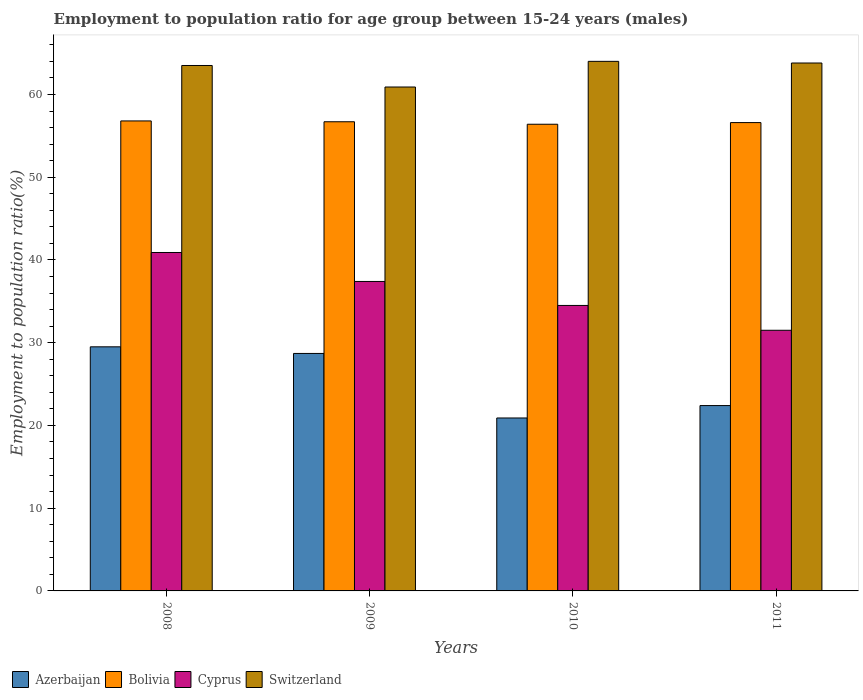How many different coloured bars are there?
Provide a short and direct response. 4. How many groups of bars are there?
Keep it short and to the point. 4. Are the number of bars on each tick of the X-axis equal?
Keep it short and to the point. Yes. In how many cases, is the number of bars for a given year not equal to the number of legend labels?
Your response must be concise. 0. What is the employment to population ratio in Cyprus in 2010?
Offer a very short reply. 34.5. Across all years, what is the minimum employment to population ratio in Bolivia?
Provide a succinct answer. 56.4. What is the total employment to population ratio in Switzerland in the graph?
Your answer should be very brief. 252.2. What is the difference between the employment to population ratio in Bolivia in 2008 and the employment to population ratio in Cyprus in 2010?
Your answer should be compact. 22.3. What is the average employment to population ratio in Cyprus per year?
Keep it short and to the point. 36.08. In the year 2010, what is the difference between the employment to population ratio in Bolivia and employment to population ratio in Azerbaijan?
Provide a succinct answer. 35.5. What is the ratio of the employment to population ratio in Cyprus in 2008 to that in 2009?
Offer a terse response. 1.09. What is the difference between the highest and the second highest employment to population ratio in Cyprus?
Provide a succinct answer. 3.5. What is the difference between the highest and the lowest employment to population ratio in Bolivia?
Provide a short and direct response. 0.4. In how many years, is the employment to population ratio in Cyprus greater than the average employment to population ratio in Cyprus taken over all years?
Offer a terse response. 2. Is the sum of the employment to population ratio in Azerbaijan in 2009 and 2010 greater than the maximum employment to population ratio in Cyprus across all years?
Your answer should be compact. Yes. Is it the case that in every year, the sum of the employment to population ratio in Switzerland and employment to population ratio in Cyprus is greater than the sum of employment to population ratio in Bolivia and employment to population ratio in Azerbaijan?
Ensure brevity in your answer.  Yes. What does the 3rd bar from the left in 2008 represents?
Provide a short and direct response. Cyprus. Is it the case that in every year, the sum of the employment to population ratio in Azerbaijan and employment to population ratio in Switzerland is greater than the employment to population ratio in Bolivia?
Provide a short and direct response. Yes. How many bars are there?
Provide a short and direct response. 16. How many years are there in the graph?
Your response must be concise. 4. Are the values on the major ticks of Y-axis written in scientific E-notation?
Offer a terse response. No. Does the graph contain any zero values?
Offer a very short reply. No. Does the graph contain grids?
Your answer should be very brief. No. How many legend labels are there?
Keep it short and to the point. 4. What is the title of the graph?
Give a very brief answer. Employment to population ratio for age group between 15-24 years (males). Does "Mexico" appear as one of the legend labels in the graph?
Provide a short and direct response. No. What is the label or title of the X-axis?
Give a very brief answer. Years. What is the Employment to population ratio(%) of Azerbaijan in 2008?
Provide a short and direct response. 29.5. What is the Employment to population ratio(%) in Bolivia in 2008?
Offer a very short reply. 56.8. What is the Employment to population ratio(%) in Cyprus in 2008?
Provide a succinct answer. 40.9. What is the Employment to population ratio(%) in Switzerland in 2008?
Provide a short and direct response. 63.5. What is the Employment to population ratio(%) of Azerbaijan in 2009?
Make the answer very short. 28.7. What is the Employment to population ratio(%) of Bolivia in 2009?
Keep it short and to the point. 56.7. What is the Employment to population ratio(%) of Cyprus in 2009?
Provide a succinct answer. 37.4. What is the Employment to population ratio(%) of Switzerland in 2009?
Provide a short and direct response. 60.9. What is the Employment to population ratio(%) in Azerbaijan in 2010?
Your response must be concise. 20.9. What is the Employment to population ratio(%) in Bolivia in 2010?
Make the answer very short. 56.4. What is the Employment to population ratio(%) of Cyprus in 2010?
Ensure brevity in your answer.  34.5. What is the Employment to population ratio(%) of Azerbaijan in 2011?
Offer a terse response. 22.4. What is the Employment to population ratio(%) in Bolivia in 2011?
Ensure brevity in your answer.  56.6. What is the Employment to population ratio(%) in Cyprus in 2011?
Your answer should be compact. 31.5. What is the Employment to population ratio(%) in Switzerland in 2011?
Your answer should be compact. 63.8. Across all years, what is the maximum Employment to population ratio(%) of Azerbaijan?
Your response must be concise. 29.5. Across all years, what is the maximum Employment to population ratio(%) in Bolivia?
Provide a succinct answer. 56.8. Across all years, what is the maximum Employment to population ratio(%) in Cyprus?
Your response must be concise. 40.9. Across all years, what is the maximum Employment to population ratio(%) of Switzerland?
Provide a short and direct response. 64. Across all years, what is the minimum Employment to population ratio(%) of Azerbaijan?
Your response must be concise. 20.9. Across all years, what is the minimum Employment to population ratio(%) of Bolivia?
Ensure brevity in your answer.  56.4. Across all years, what is the minimum Employment to population ratio(%) of Cyprus?
Make the answer very short. 31.5. Across all years, what is the minimum Employment to population ratio(%) in Switzerland?
Ensure brevity in your answer.  60.9. What is the total Employment to population ratio(%) in Azerbaijan in the graph?
Your answer should be very brief. 101.5. What is the total Employment to population ratio(%) in Bolivia in the graph?
Offer a terse response. 226.5. What is the total Employment to population ratio(%) in Cyprus in the graph?
Keep it short and to the point. 144.3. What is the total Employment to population ratio(%) of Switzerland in the graph?
Your response must be concise. 252.2. What is the difference between the Employment to population ratio(%) of Bolivia in 2008 and that in 2009?
Give a very brief answer. 0.1. What is the difference between the Employment to population ratio(%) in Cyprus in 2008 and that in 2009?
Give a very brief answer. 3.5. What is the difference between the Employment to population ratio(%) of Switzerland in 2008 and that in 2009?
Your answer should be very brief. 2.6. What is the difference between the Employment to population ratio(%) in Bolivia in 2008 and that in 2010?
Offer a very short reply. 0.4. What is the difference between the Employment to population ratio(%) in Azerbaijan in 2008 and that in 2011?
Give a very brief answer. 7.1. What is the difference between the Employment to population ratio(%) in Bolivia in 2008 and that in 2011?
Make the answer very short. 0.2. What is the difference between the Employment to population ratio(%) of Cyprus in 2008 and that in 2011?
Give a very brief answer. 9.4. What is the difference between the Employment to population ratio(%) of Switzerland in 2008 and that in 2011?
Ensure brevity in your answer.  -0.3. What is the difference between the Employment to population ratio(%) in Azerbaijan in 2009 and that in 2010?
Offer a very short reply. 7.8. What is the difference between the Employment to population ratio(%) of Bolivia in 2009 and that in 2010?
Give a very brief answer. 0.3. What is the difference between the Employment to population ratio(%) in Cyprus in 2009 and that in 2010?
Your answer should be very brief. 2.9. What is the difference between the Employment to population ratio(%) of Switzerland in 2009 and that in 2010?
Your answer should be very brief. -3.1. What is the difference between the Employment to population ratio(%) of Azerbaijan in 2009 and that in 2011?
Ensure brevity in your answer.  6.3. What is the difference between the Employment to population ratio(%) of Cyprus in 2009 and that in 2011?
Give a very brief answer. 5.9. What is the difference between the Employment to population ratio(%) in Switzerland in 2009 and that in 2011?
Provide a succinct answer. -2.9. What is the difference between the Employment to population ratio(%) in Cyprus in 2010 and that in 2011?
Ensure brevity in your answer.  3. What is the difference between the Employment to population ratio(%) of Azerbaijan in 2008 and the Employment to population ratio(%) of Bolivia in 2009?
Offer a terse response. -27.2. What is the difference between the Employment to population ratio(%) of Azerbaijan in 2008 and the Employment to population ratio(%) of Switzerland in 2009?
Your answer should be compact. -31.4. What is the difference between the Employment to population ratio(%) of Bolivia in 2008 and the Employment to population ratio(%) of Switzerland in 2009?
Your response must be concise. -4.1. What is the difference between the Employment to population ratio(%) in Azerbaijan in 2008 and the Employment to population ratio(%) in Bolivia in 2010?
Keep it short and to the point. -26.9. What is the difference between the Employment to population ratio(%) in Azerbaijan in 2008 and the Employment to population ratio(%) in Cyprus in 2010?
Offer a very short reply. -5. What is the difference between the Employment to population ratio(%) of Azerbaijan in 2008 and the Employment to population ratio(%) of Switzerland in 2010?
Make the answer very short. -34.5. What is the difference between the Employment to population ratio(%) of Bolivia in 2008 and the Employment to population ratio(%) of Cyprus in 2010?
Your answer should be very brief. 22.3. What is the difference between the Employment to population ratio(%) in Cyprus in 2008 and the Employment to population ratio(%) in Switzerland in 2010?
Your answer should be compact. -23.1. What is the difference between the Employment to population ratio(%) of Azerbaijan in 2008 and the Employment to population ratio(%) of Bolivia in 2011?
Give a very brief answer. -27.1. What is the difference between the Employment to population ratio(%) in Azerbaijan in 2008 and the Employment to population ratio(%) in Switzerland in 2011?
Make the answer very short. -34.3. What is the difference between the Employment to population ratio(%) in Bolivia in 2008 and the Employment to population ratio(%) in Cyprus in 2011?
Your answer should be very brief. 25.3. What is the difference between the Employment to population ratio(%) in Cyprus in 2008 and the Employment to population ratio(%) in Switzerland in 2011?
Ensure brevity in your answer.  -22.9. What is the difference between the Employment to population ratio(%) in Azerbaijan in 2009 and the Employment to population ratio(%) in Bolivia in 2010?
Provide a short and direct response. -27.7. What is the difference between the Employment to population ratio(%) in Azerbaijan in 2009 and the Employment to population ratio(%) in Cyprus in 2010?
Keep it short and to the point. -5.8. What is the difference between the Employment to population ratio(%) in Azerbaijan in 2009 and the Employment to population ratio(%) in Switzerland in 2010?
Offer a terse response. -35.3. What is the difference between the Employment to population ratio(%) in Bolivia in 2009 and the Employment to population ratio(%) in Switzerland in 2010?
Your answer should be very brief. -7.3. What is the difference between the Employment to population ratio(%) of Cyprus in 2009 and the Employment to population ratio(%) of Switzerland in 2010?
Provide a short and direct response. -26.6. What is the difference between the Employment to population ratio(%) of Azerbaijan in 2009 and the Employment to population ratio(%) of Bolivia in 2011?
Your response must be concise. -27.9. What is the difference between the Employment to population ratio(%) in Azerbaijan in 2009 and the Employment to population ratio(%) in Cyprus in 2011?
Your response must be concise. -2.8. What is the difference between the Employment to population ratio(%) in Azerbaijan in 2009 and the Employment to population ratio(%) in Switzerland in 2011?
Your answer should be very brief. -35.1. What is the difference between the Employment to population ratio(%) of Bolivia in 2009 and the Employment to population ratio(%) of Cyprus in 2011?
Ensure brevity in your answer.  25.2. What is the difference between the Employment to population ratio(%) of Bolivia in 2009 and the Employment to population ratio(%) of Switzerland in 2011?
Provide a succinct answer. -7.1. What is the difference between the Employment to population ratio(%) in Cyprus in 2009 and the Employment to population ratio(%) in Switzerland in 2011?
Your answer should be very brief. -26.4. What is the difference between the Employment to population ratio(%) of Azerbaijan in 2010 and the Employment to population ratio(%) of Bolivia in 2011?
Ensure brevity in your answer.  -35.7. What is the difference between the Employment to population ratio(%) in Azerbaijan in 2010 and the Employment to population ratio(%) in Switzerland in 2011?
Ensure brevity in your answer.  -42.9. What is the difference between the Employment to population ratio(%) of Bolivia in 2010 and the Employment to population ratio(%) of Cyprus in 2011?
Your response must be concise. 24.9. What is the difference between the Employment to population ratio(%) in Bolivia in 2010 and the Employment to population ratio(%) in Switzerland in 2011?
Make the answer very short. -7.4. What is the difference between the Employment to population ratio(%) in Cyprus in 2010 and the Employment to population ratio(%) in Switzerland in 2011?
Provide a short and direct response. -29.3. What is the average Employment to population ratio(%) in Azerbaijan per year?
Your answer should be compact. 25.38. What is the average Employment to population ratio(%) in Bolivia per year?
Provide a short and direct response. 56.62. What is the average Employment to population ratio(%) of Cyprus per year?
Your answer should be compact. 36.08. What is the average Employment to population ratio(%) in Switzerland per year?
Your answer should be compact. 63.05. In the year 2008, what is the difference between the Employment to population ratio(%) of Azerbaijan and Employment to population ratio(%) of Bolivia?
Give a very brief answer. -27.3. In the year 2008, what is the difference between the Employment to population ratio(%) in Azerbaijan and Employment to population ratio(%) in Cyprus?
Give a very brief answer. -11.4. In the year 2008, what is the difference between the Employment to population ratio(%) of Azerbaijan and Employment to population ratio(%) of Switzerland?
Your response must be concise. -34. In the year 2008, what is the difference between the Employment to population ratio(%) in Bolivia and Employment to population ratio(%) in Switzerland?
Ensure brevity in your answer.  -6.7. In the year 2008, what is the difference between the Employment to population ratio(%) in Cyprus and Employment to population ratio(%) in Switzerland?
Keep it short and to the point. -22.6. In the year 2009, what is the difference between the Employment to population ratio(%) in Azerbaijan and Employment to population ratio(%) in Bolivia?
Offer a terse response. -28. In the year 2009, what is the difference between the Employment to population ratio(%) in Azerbaijan and Employment to population ratio(%) in Switzerland?
Offer a terse response. -32.2. In the year 2009, what is the difference between the Employment to population ratio(%) of Bolivia and Employment to population ratio(%) of Cyprus?
Give a very brief answer. 19.3. In the year 2009, what is the difference between the Employment to population ratio(%) in Bolivia and Employment to population ratio(%) in Switzerland?
Offer a very short reply. -4.2. In the year 2009, what is the difference between the Employment to population ratio(%) of Cyprus and Employment to population ratio(%) of Switzerland?
Ensure brevity in your answer.  -23.5. In the year 2010, what is the difference between the Employment to population ratio(%) in Azerbaijan and Employment to population ratio(%) in Bolivia?
Provide a short and direct response. -35.5. In the year 2010, what is the difference between the Employment to population ratio(%) in Azerbaijan and Employment to population ratio(%) in Switzerland?
Your answer should be very brief. -43.1. In the year 2010, what is the difference between the Employment to population ratio(%) in Bolivia and Employment to population ratio(%) in Cyprus?
Your response must be concise. 21.9. In the year 2010, what is the difference between the Employment to population ratio(%) of Cyprus and Employment to population ratio(%) of Switzerland?
Provide a succinct answer. -29.5. In the year 2011, what is the difference between the Employment to population ratio(%) of Azerbaijan and Employment to population ratio(%) of Bolivia?
Your answer should be compact. -34.2. In the year 2011, what is the difference between the Employment to population ratio(%) of Azerbaijan and Employment to population ratio(%) of Cyprus?
Ensure brevity in your answer.  -9.1. In the year 2011, what is the difference between the Employment to population ratio(%) in Azerbaijan and Employment to population ratio(%) in Switzerland?
Make the answer very short. -41.4. In the year 2011, what is the difference between the Employment to population ratio(%) of Bolivia and Employment to population ratio(%) of Cyprus?
Make the answer very short. 25.1. In the year 2011, what is the difference between the Employment to population ratio(%) in Cyprus and Employment to population ratio(%) in Switzerland?
Provide a short and direct response. -32.3. What is the ratio of the Employment to population ratio(%) in Azerbaijan in 2008 to that in 2009?
Provide a succinct answer. 1.03. What is the ratio of the Employment to population ratio(%) of Bolivia in 2008 to that in 2009?
Make the answer very short. 1. What is the ratio of the Employment to population ratio(%) in Cyprus in 2008 to that in 2009?
Offer a very short reply. 1.09. What is the ratio of the Employment to population ratio(%) in Switzerland in 2008 to that in 2009?
Your response must be concise. 1.04. What is the ratio of the Employment to population ratio(%) in Azerbaijan in 2008 to that in 2010?
Your response must be concise. 1.41. What is the ratio of the Employment to population ratio(%) of Bolivia in 2008 to that in 2010?
Make the answer very short. 1.01. What is the ratio of the Employment to population ratio(%) of Cyprus in 2008 to that in 2010?
Ensure brevity in your answer.  1.19. What is the ratio of the Employment to population ratio(%) of Switzerland in 2008 to that in 2010?
Make the answer very short. 0.99. What is the ratio of the Employment to population ratio(%) of Azerbaijan in 2008 to that in 2011?
Offer a very short reply. 1.32. What is the ratio of the Employment to population ratio(%) of Bolivia in 2008 to that in 2011?
Offer a terse response. 1. What is the ratio of the Employment to population ratio(%) of Cyprus in 2008 to that in 2011?
Make the answer very short. 1.3. What is the ratio of the Employment to population ratio(%) of Switzerland in 2008 to that in 2011?
Provide a succinct answer. 1. What is the ratio of the Employment to population ratio(%) of Azerbaijan in 2009 to that in 2010?
Ensure brevity in your answer.  1.37. What is the ratio of the Employment to population ratio(%) of Cyprus in 2009 to that in 2010?
Your response must be concise. 1.08. What is the ratio of the Employment to population ratio(%) in Switzerland in 2009 to that in 2010?
Give a very brief answer. 0.95. What is the ratio of the Employment to population ratio(%) of Azerbaijan in 2009 to that in 2011?
Keep it short and to the point. 1.28. What is the ratio of the Employment to population ratio(%) of Cyprus in 2009 to that in 2011?
Provide a short and direct response. 1.19. What is the ratio of the Employment to population ratio(%) in Switzerland in 2009 to that in 2011?
Keep it short and to the point. 0.95. What is the ratio of the Employment to population ratio(%) of Azerbaijan in 2010 to that in 2011?
Make the answer very short. 0.93. What is the ratio of the Employment to population ratio(%) of Cyprus in 2010 to that in 2011?
Your answer should be compact. 1.1. What is the ratio of the Employment to population ratio(%) in Switzerland in 2010 to that in 2011?
Your response must be concise. 1. What is the difference between the highest and the second highest Employment to population ratio(%) of Azerbaijan?
Your answer should be very brief. 0.8. What is the difference between the highest and the lowest Employment to population ratio(%) in Azerbaijan?
Your answer should be very brief. 8.6. What is the difference between the highest and the lowest Employment to population ratio(%) in Cyprus?
Your response must be concise. 9.4. What is the difference between the highest and the lowest Employment to population ratio(%) of Switzerland?
Give a very brief answer. 3.1. 